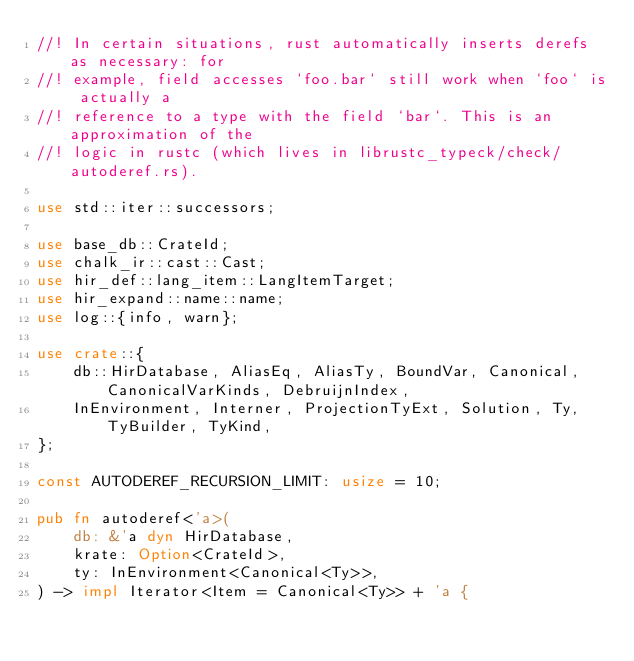Convert code to text. <code><loc_0><loc_0><loc_500><loc_500><_Rust_>//! In certain situations, rust automatically inserts derefs as necessary: for
//! example, field accesses `foo.bar` still work when `foo` is actually a
//! reference to a type with the field `bar`. This is an approximation of the
//! logic in rustc (which lives in librustc_typeck/check/autoderef.rs).

use std::iter::successors;

use base_db::CrateId;
use chalk_ir::cast::Cast;
use hir_def::lang_item::LangItemTarget;
use hir_expand::name::name;
use log::{info, warn};

use crate::{
    db::HirDatabase, AliasEq, AliasTy, BoundVar, Canonical, CanonicalVarKinds, DebruijnIndex,
    InEnvironment, Interner, ProjectionTyExt, Solution, Ty, TyBuilder, TyKind,
};

const AUTODEREF_RECURSION_LIMIT: usize = 10;

pub fn autoderef<'a>(
    db: &'a dyn HirDatabase,
    krate: Option<CrateId>,
    ty: InEnvironment<Canonical<Ty>>,
) -> impl Iterator<Item = Canonical<Ty>> + 'a {</code> 